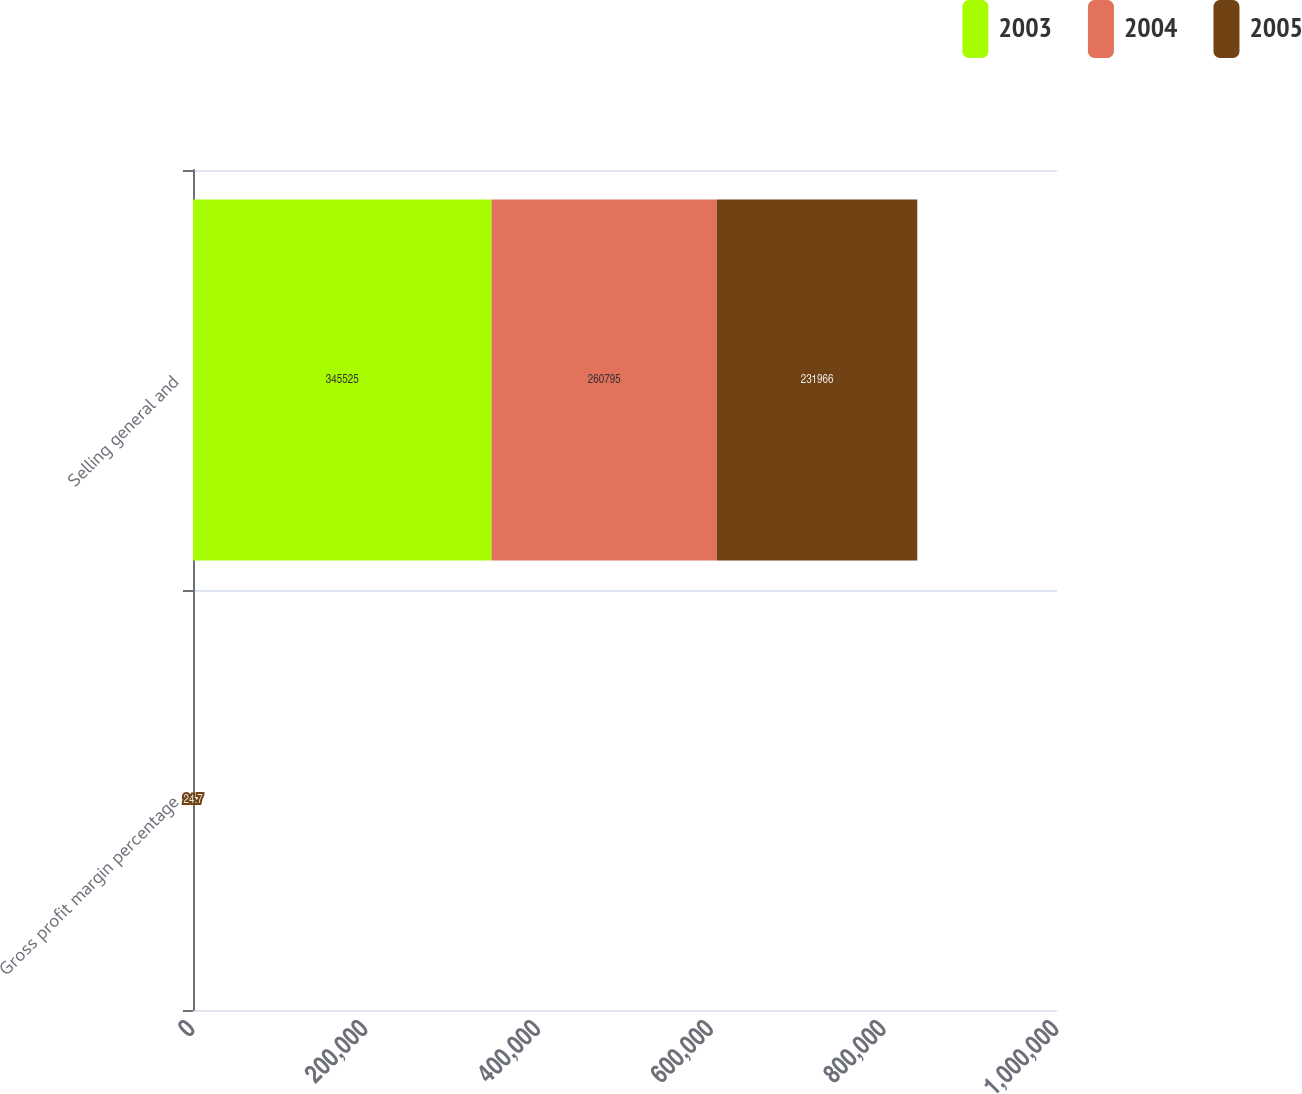Convert chart to OTSL. <chart><loc_0><loc_0><loc_500><loc_500><stacked_bar_chart><ecel><fcel>Gross profit margin percentage<fcel>Selling general and<nl><fcel>2003<fcel>27.8<fcel>345525<nl><fcel>2004<fcel>25.7<fcel>260795<nl><fcel>2005<fcel>24.7<fcel>231966<nl></chart> 